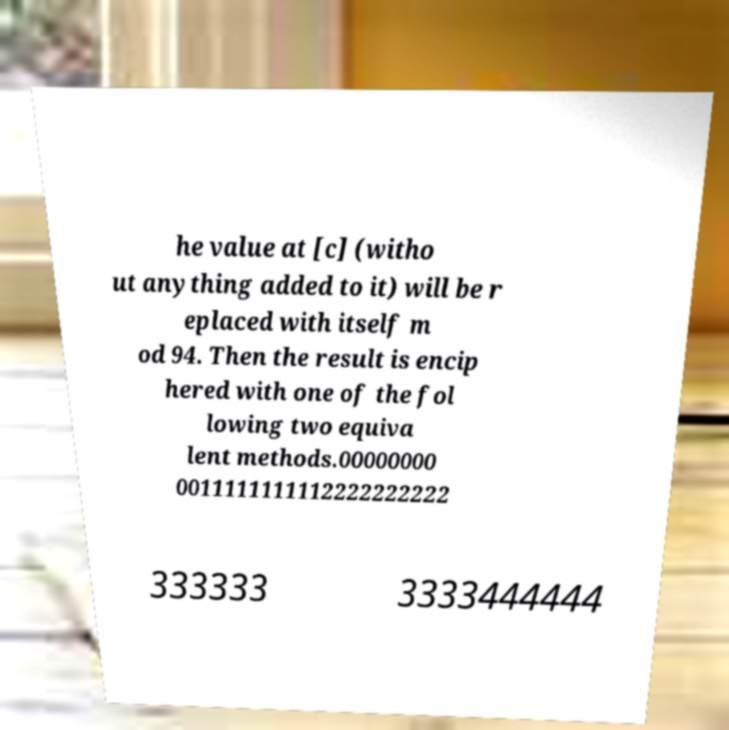What messages or text are displayed in this image? I need them in a readable, typed format. he value at [c] (witho ut anything added to it) will be r eplaced with itself m od 94. Then the result is encip hered with one of the fol lowing two equiva lent methods.00000000 0011111111112222222222 333333 3333444444 